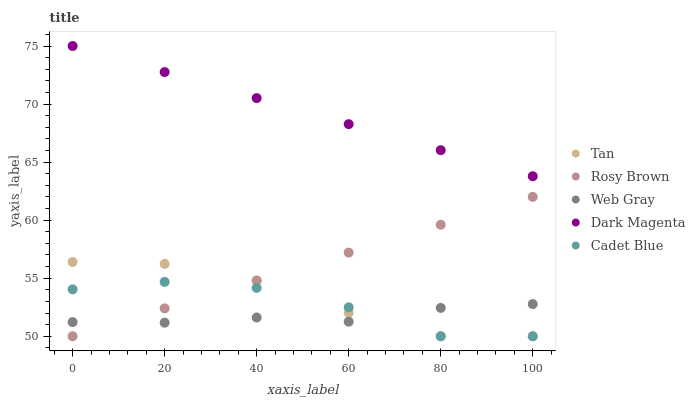Does Web Gray have the minimum area under the curve?
Answer yes or no. Yes. Does Dark Magenta have the maximum area under the curve?
Answer yes or no. Yes. Does Tan have the minimum area under the curve?
Answer yes or no. No. Does Tan have the maximum area under the curve?
Answer yes or no. No. Is Dark Magenta the smoothest?
Answer yes or no. Yes. Is Cadet Blue the roughest?
Answer yes or no. Yes. Is Tan the smoothest?
Answer yes or no. No. Is Tan the roughest?
Answer yes or no. No. Does Cadet Blue have the lowest value?
Answer yes or no. Yes. Does Web Gray have the lowest value?
Answer yes or no. No. Does Dark Magenta have the highest value?
Answer yes or no. Yes. Does Tan have the highest value?
Answer yes or no. No. Is Rosy Brown less than Dark Magenta?
Answer yes or no. Yes. Is Dark Magenta greater than Rosy Brown?
Answer yes or no. Yes. Does Tan intersect Rosy Brown?
Answer yes or no. Yes. Is Tan less than Rosy Brown?
Answer yes or no. No. Is Tan greater than Rosy Brown?
Answer yes or no. No. Does Rosy Brown intersect Dark Magenta?
Answer yes or no. No. 